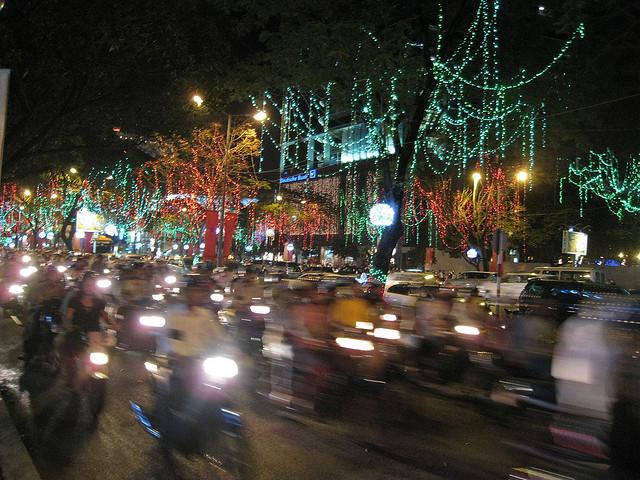How many cars are under the light post?
Short answer required. 2. Is it dark outside?
Quick response, please. Yes. What kind of scene is this?
Keep it brief. Christmas street. How many moving lanes of traffic are there?
Concise answer only. 4. Are there more motorcycles than cars?
Keep it brief. Yes. 